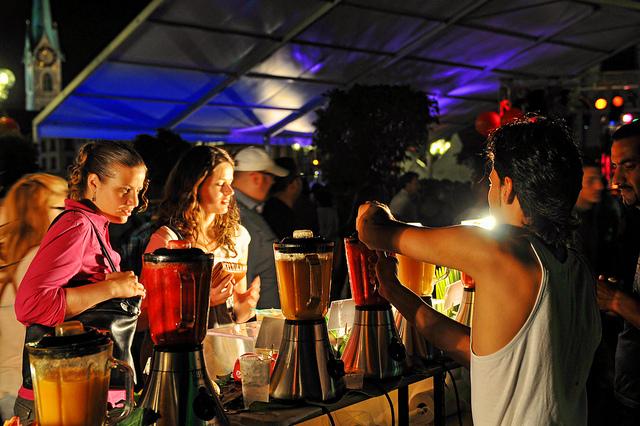What color is bartender's shirt?
Concise answer only. White. What is the woman in the pink shirt holding?
Give a very brief answer. Purse. How many blenders are visible?
Write a very short answer. 5. What kind of demonstration is happening here?
Write a very short answer. Party. 